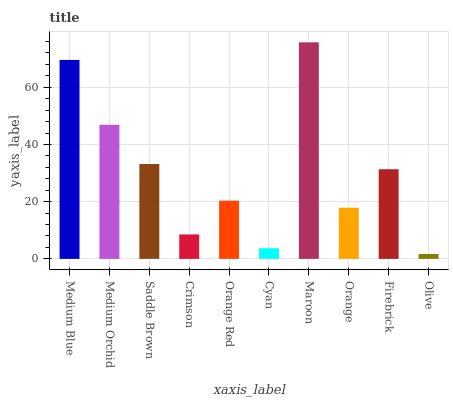Is Olive the minimum?
Answer yes or no. Yes. Is Maroon the maximum?
Answer yes or no. Yes. Is Medium Orchid the minimum?
Answer yes or no. No. Is Medium Orchid the maximum?
Answer yes or no. No. Is Medium Blue greater than Medium Orchid?
Answer yes or no. Yes. Is Medium Orchid less than Medium Blue?
Answer yes or no. Yes. Is Medium Orchid greater than Medium Blue?
Answer yes or no. No. Is Medium Blue less than Medium Orchid?
Answer yes or no. No. Is Firebrick the high median?
Answer yes or no. Yes. Is Orange Red the low median?
Answer yes or no. Yes. Is Olive the high median?
Answer yes or no. No. Is Orange the low median?
Answer yes or no. No. 